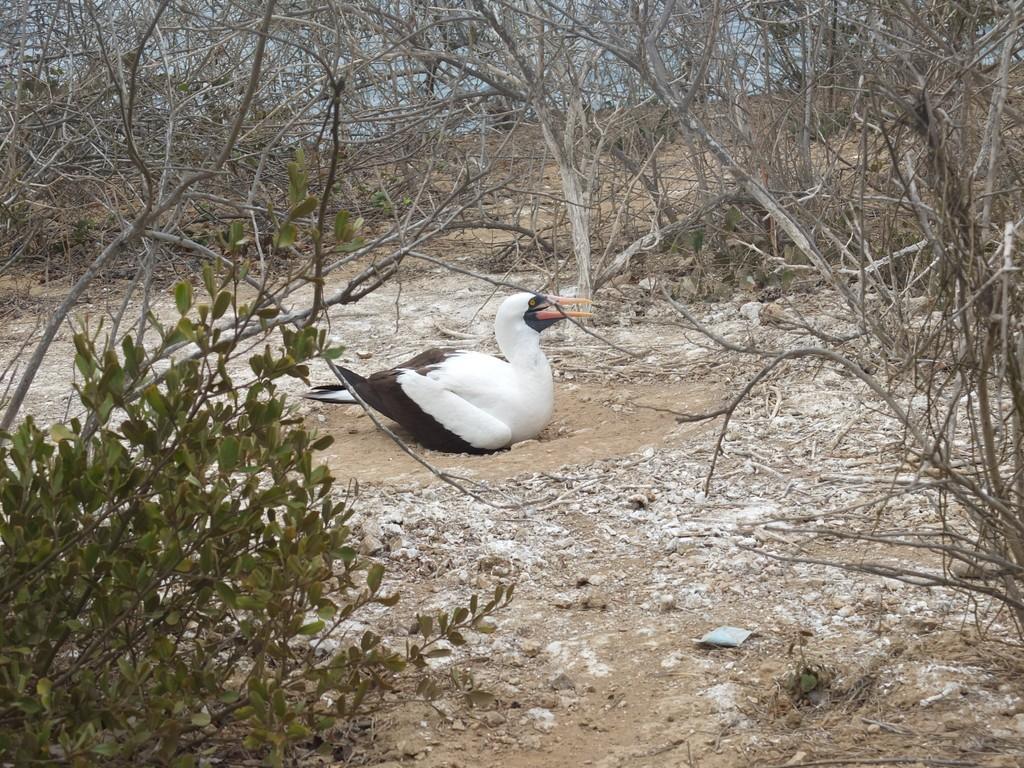In one or two sentences, can you explain what this image depicts? This picture shows a bird. It is white and black in color and we see trees and a plant. 